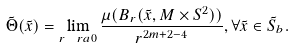Convert formula to latex. <formula><loc_0><loc_0><loc_500><loc_500>\tilde { \Theta } ( \tilde { x } ) = \lim _ { r \ r a 0 } \frac { \mu ( B _ { r } ( \tilde { x } , M \times S ^ { 2 } ) ) } { r ^ { 2 m + 2 - 4 } } , \forall \tilde { x } \in \tilde { S } _ { b } .</formula> 